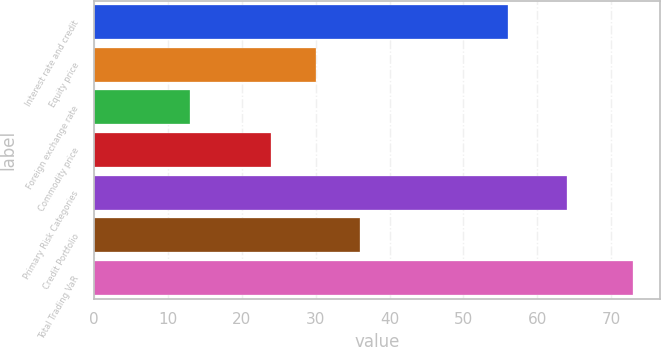Convert chart to OTSL. <chart><loc_0><loc_0><loc_500><loc_500><bar_chart><fcel>Interest rate and credit<fcel>Equity price<fcel>Foreign exchange rate<fcel>Commodity price<fcel>Primary Risk Categories<fcel>Credit Portfolio<fcel>Total Trading VaR<nl><fcel>56<fcel>30<fcel>13<fcel>24<fcel>64<fcel>36<fcel>73<nl></chart> 